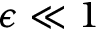<formula> <loc_0><loc_0><loc_500><loc_500>\epsilon \ll 1</formula> 